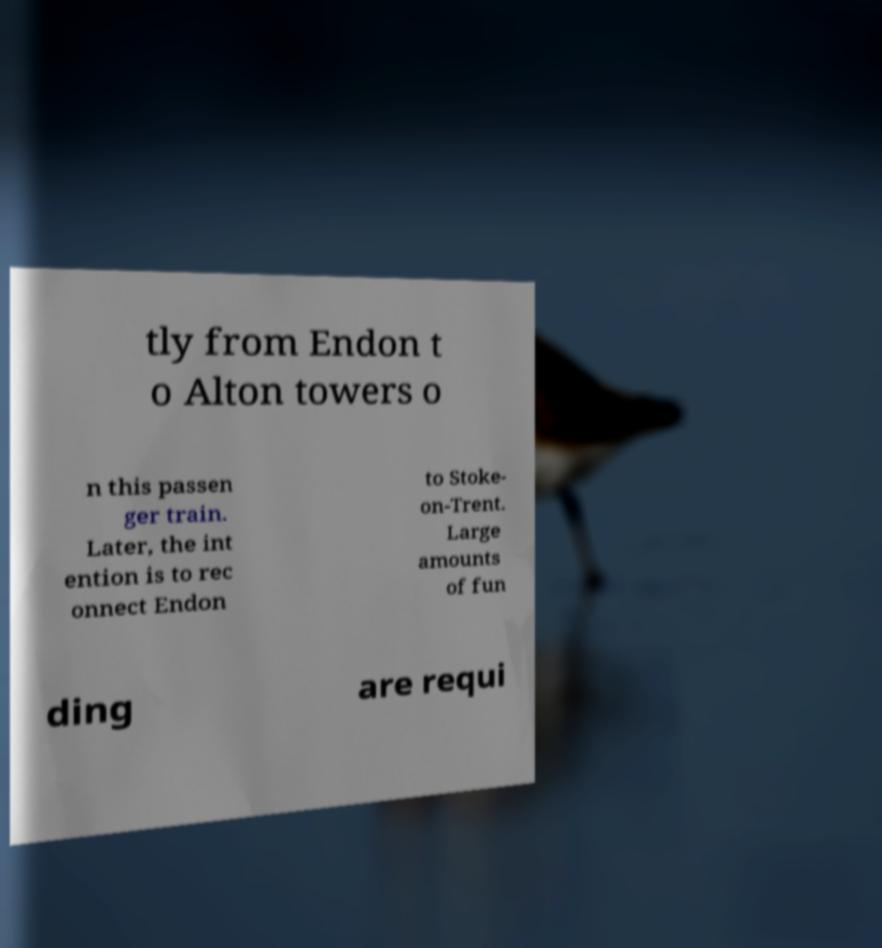There's text embedded in this image that I need extracted. Can you transcribe it verbatim? tly from Endon t o Alton towers o n this passen ger train. Later, the int ention is to rec onnect Endon to Stoke- on-Trent. Large amounts of fun ding are requi 